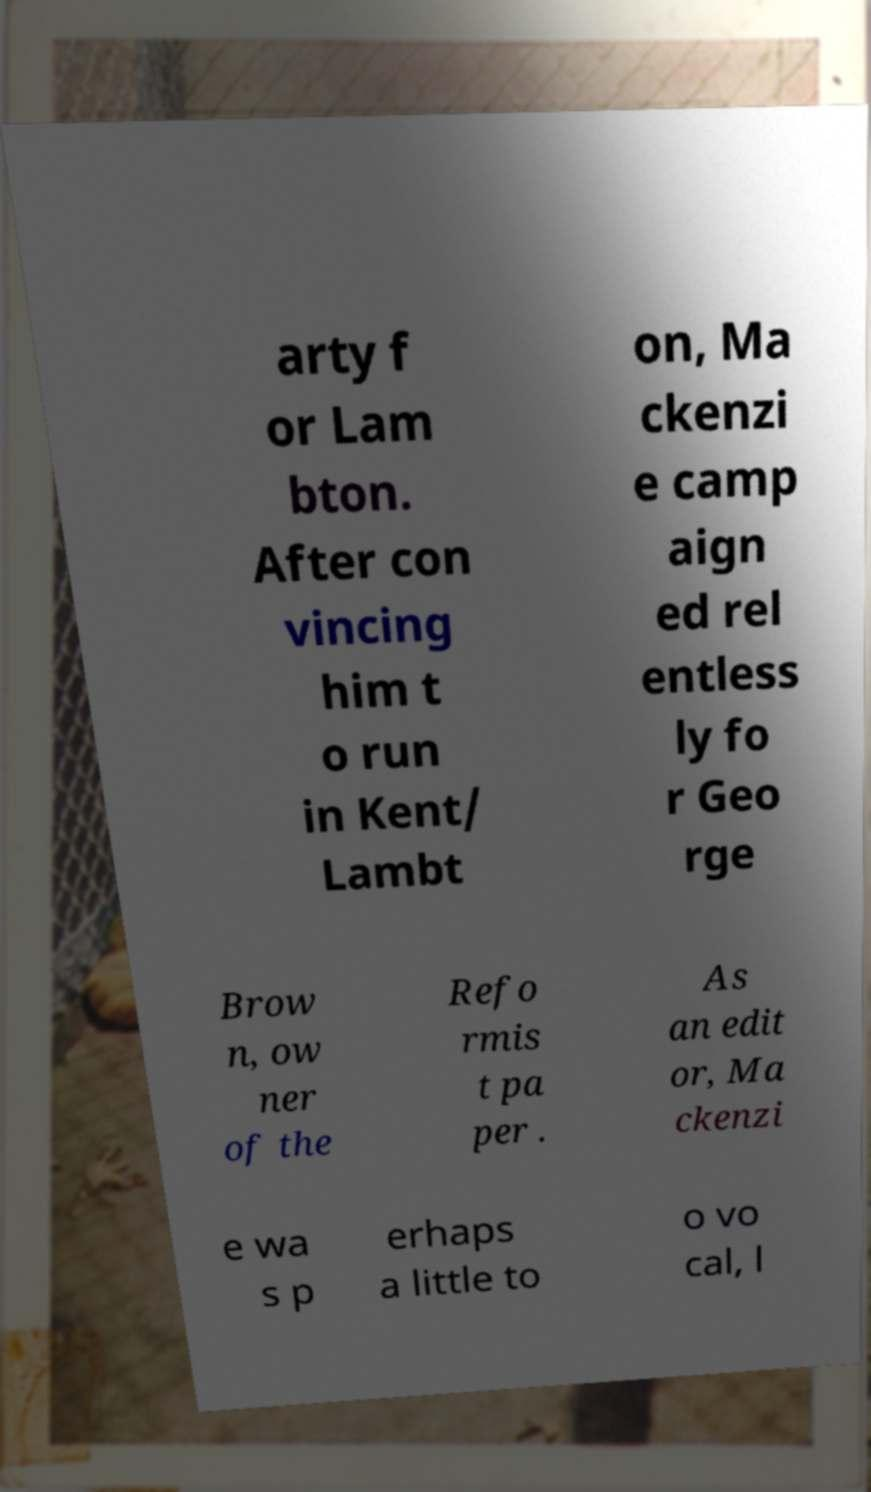For documentation purposes, I need the text within this image transcribed. Could you provide that? arty f or Lam bton. After con vincing him t o run in Kent/ Lambt on, Ma ckenzi e camp aign ed rel entless ly fo r Geo rge Brow n, ow ner of the Refo rmis t pa per . As an edit or, Ma ckenzi e wa s p erhaps a little to o vo cal, l 